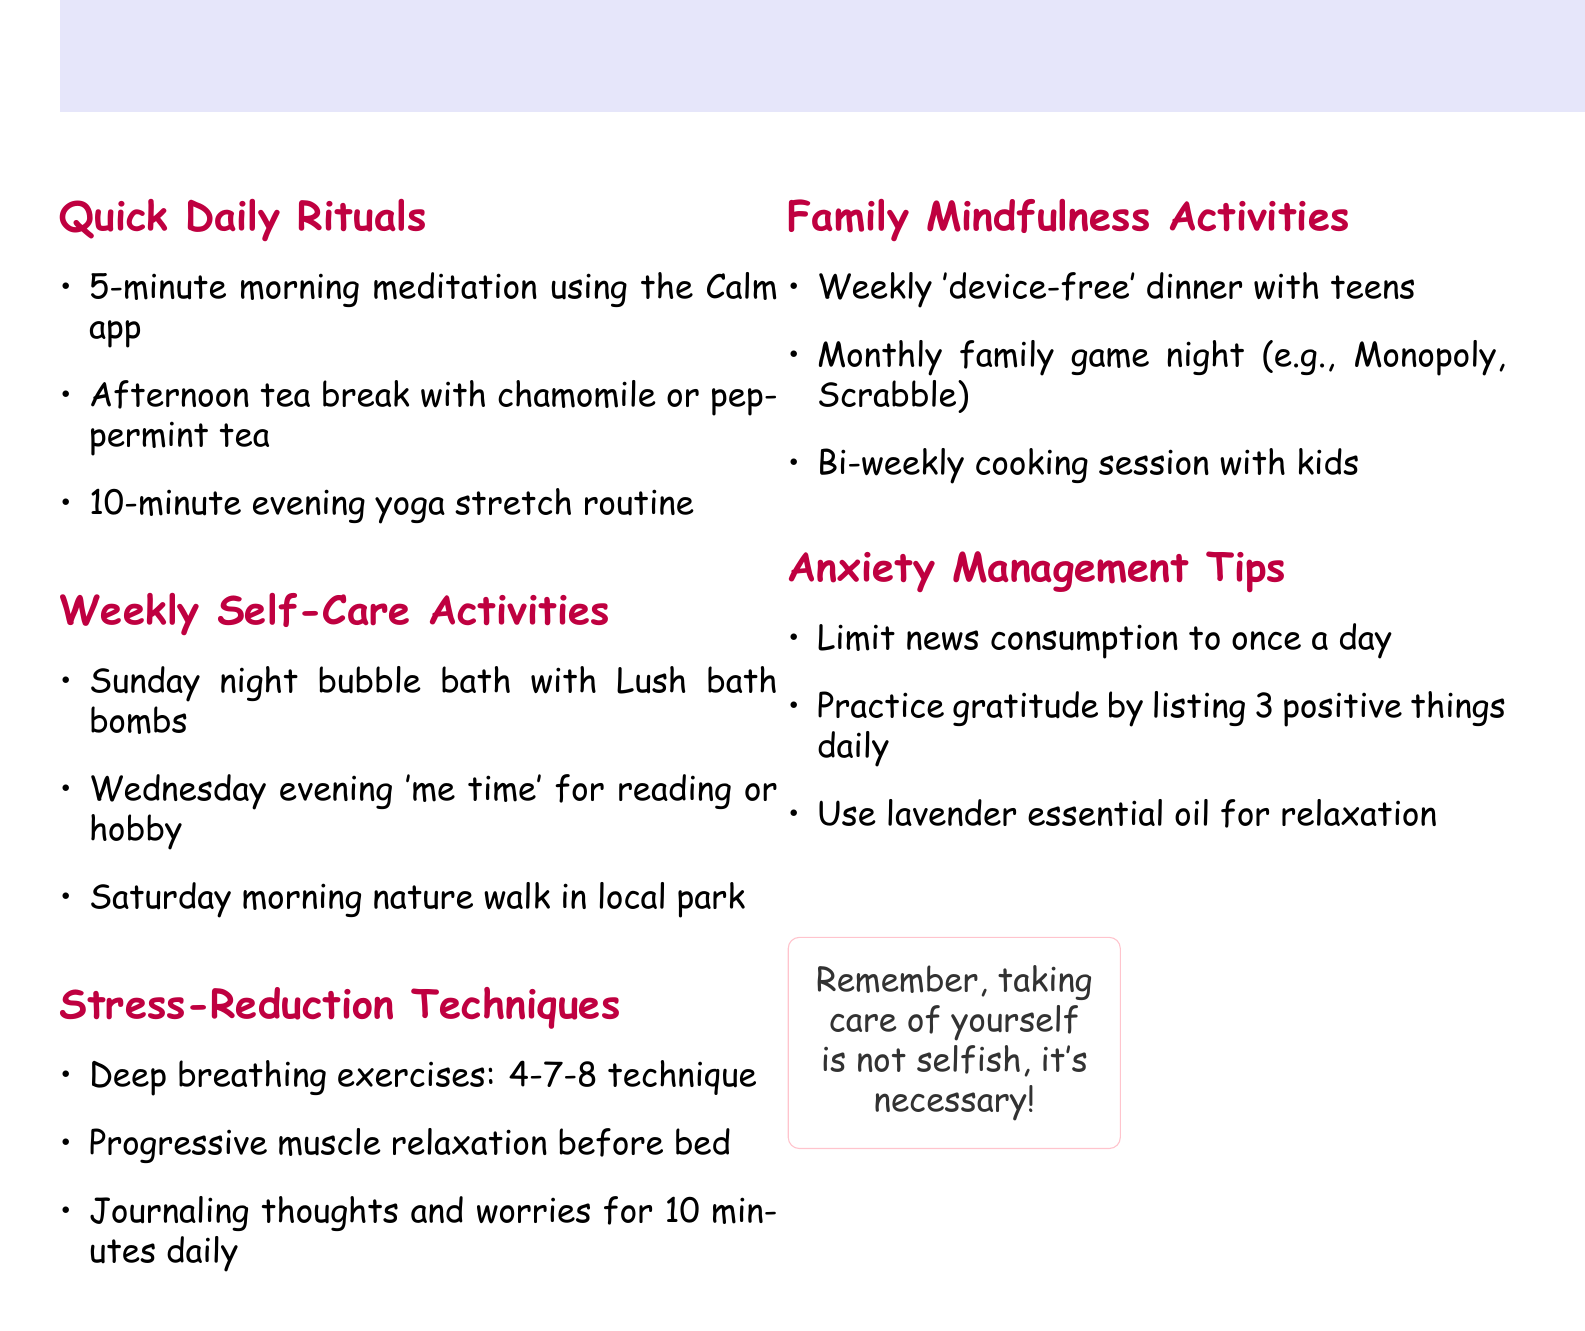What is the title of the document? The title is prominently displayed at the top of the document as the main heading.
Answer: Self-Care and Mindfulness for the Busy Mom How long is the morning meditation? The duration of the morning meditation is specified in the Quick Daily Rituals section.
Answer: 5 minutes What beverage is suggested for the afternoon tea break? The suggestions for beverages during the afternoon tea break are listed in the Quick Daily Rituals section.
Answer: Chamomile or peppermint tea Which night is reserved for a bubble bath? The specific day mentioned for the bubble bath is outlined in the Weekly Self-Care Activities section.
Answer: Sunday night What breathing technique is recommended for stress reduction? The technique is explicitly stated in the Stress-Reduction Techniques section.
Answer: 4-7-8 technique How often should gratitude practice be done? The frequency of the gratitude practice is indicated within the Anxiety Management Tips section.
Answer: Daily In which section can you find ideas for family activities? The relevant section will mention family-oriented activities for mindfulness.
Answer: Family Mindfulness Activities What is the main purpose emphasized in the document's closing? The final thought emphasizes a particular attitude toward self-care, which reflects the document's overall theme.
Answer: Necessary 